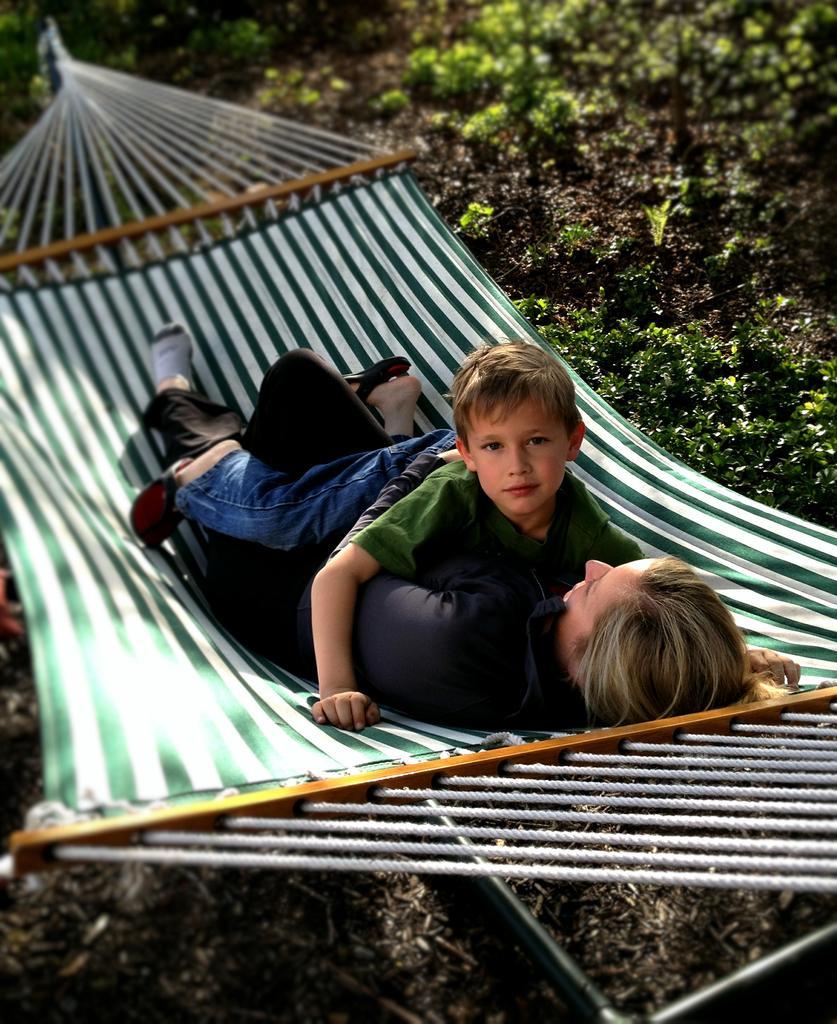Please provide a concise description of this image. This image is clicked outside. There is a person and a kid. This looks like a swing. There are plants on the right side. 